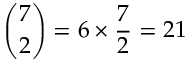<formula> <loc_0><loc_0><loc_500><loc_500>{ \binom { 7 } { 2 } } = 6 \times { \frac { 7 } { 2 } } = 2 1</formula> 